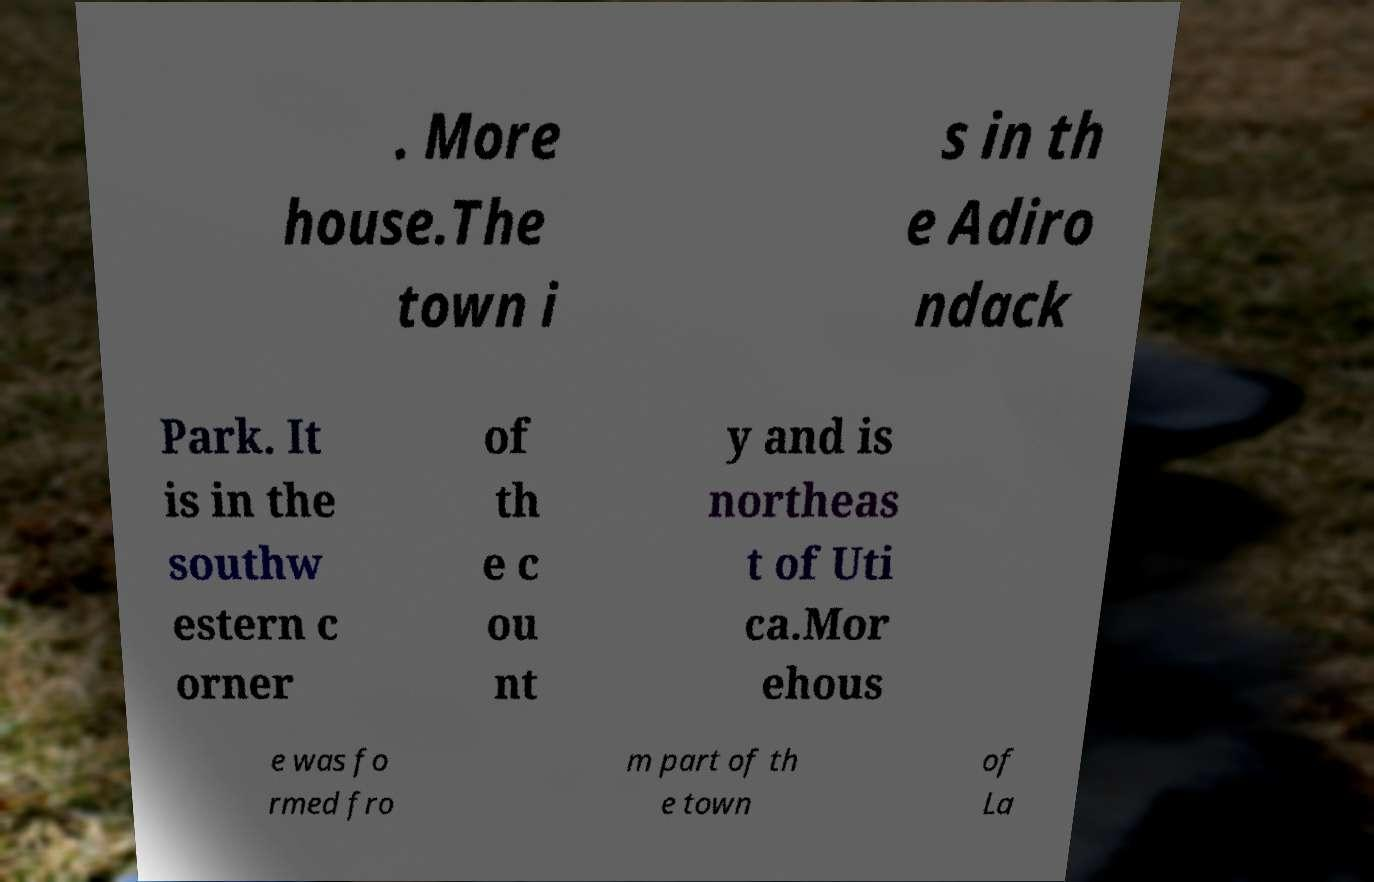There's text embedded in this image that I need extracted. Can you transcribe it verbatim? . More house.The town i s in th e Adiro ndack Park. It is in the southw estern c orner of th e c ou nt y and is northeas t of Uti ca.Mor ehous e was fo rmed fro m part of th e town of La 